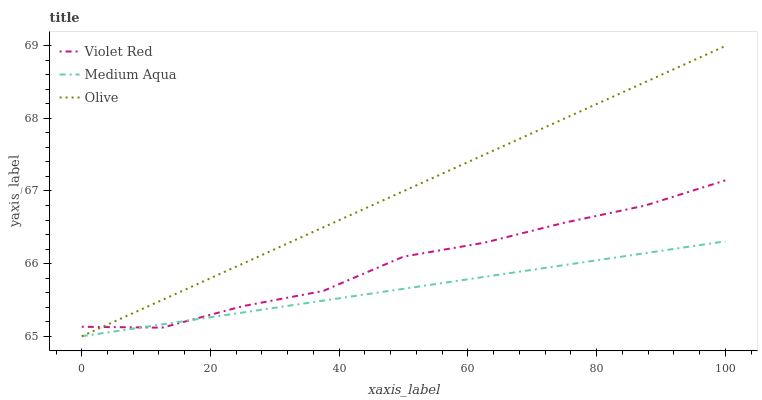Does Violet Red have the minimum area under the curve?
Answer yes or no. No. Does Violet Red have the maximum area under the curve?
Answer yes or no. No. Is Medium Aqua the smoothest?
Answer yes or no. No. Is Medium Aqua the roughest?
Answer yes or no. No. Does Violet Red have the lowest value?
Answer yes or no. No. Does Violet Red have the highest value?
Answer yes or no. No. 